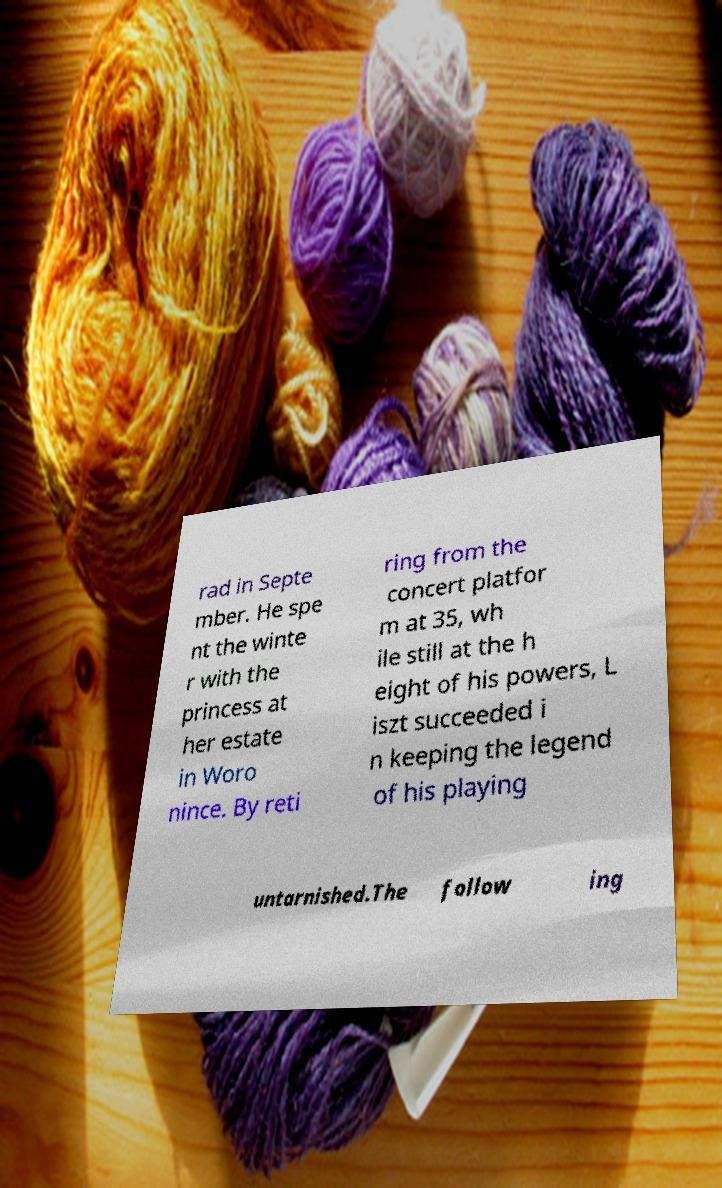Can you read and provide the text displayed in the image?This photo seems to have some interesting text. Can you extract and type it out for me? rad in Septe mber. He spe nt the winte r with the princess at her estate in Woro nince. By reti ring from the concert platfor m at 35, wh ile still at the h eight of his powers, L iszt succeeded i n keeping the legend of his playing untarnished.The follow ing 